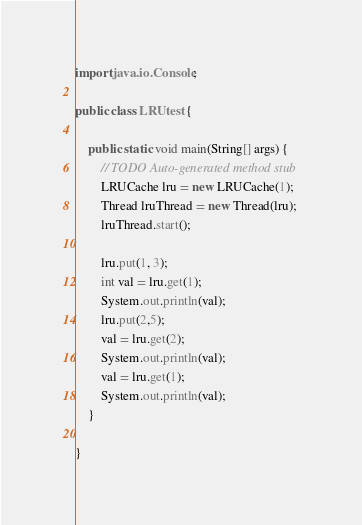Convert code to text. <code><loc_0><loc_0><loc_500><loc_500><_Java_>import java.io.Console;

public class LRUtest {

	public static void main(String[] args) {
		// TODO Auto-generated method stub
		LRUCache lru = new LRUCache(1);
		Thread lruThread = new Thread(lru);
		lruThread.start();
		
		lru.put(1, 3);
		int val = lru.get(1);
		System.out.println(val);
		lru.put(2,5);
		val = lru.get(2);
		System.out.println(val);
		val = lru.get(1);
		System.out.println(val);
	}

}
</code> 